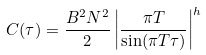Convert formula to latex. <formula><loc_0><loc_0><loc_500><loc_500>C ( \tau ) = \frac { B ^ { 2 } N ^ { 2 } } { 2 } \left | \frac { \pi T } { \sin ( \pi T \tau ) } \right | ^ { h }</formula> 